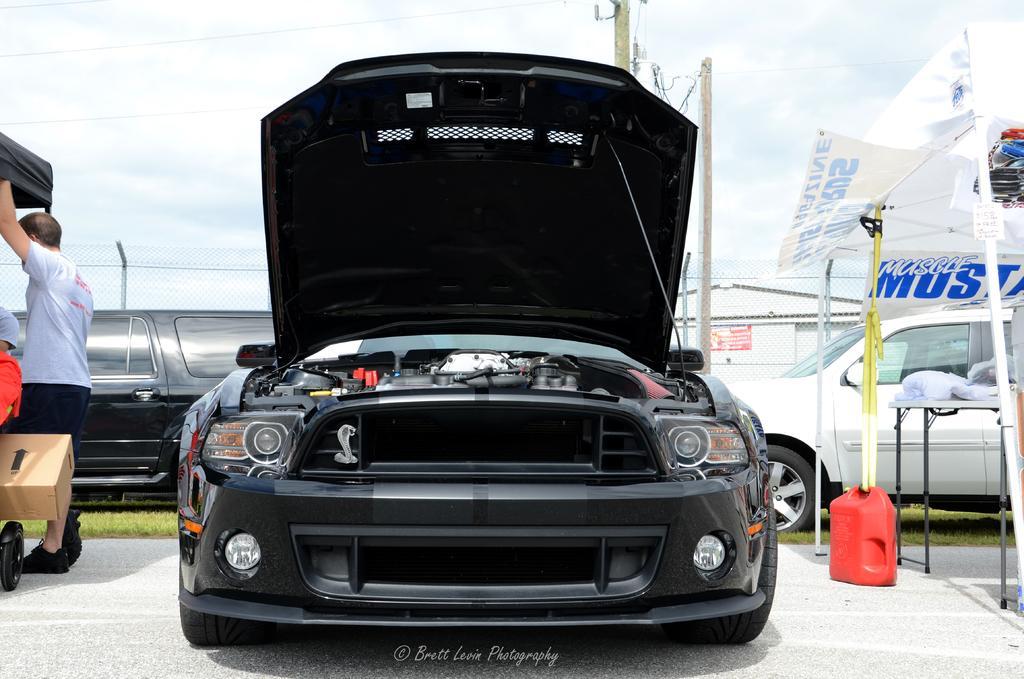Can you describe this image briefly? This image is clicked outside. There are cars in the middle. There is a person on the left side. There is a box on the left side. There is a tent on the right side. There is a fence in the middle. There is sky at the top. 